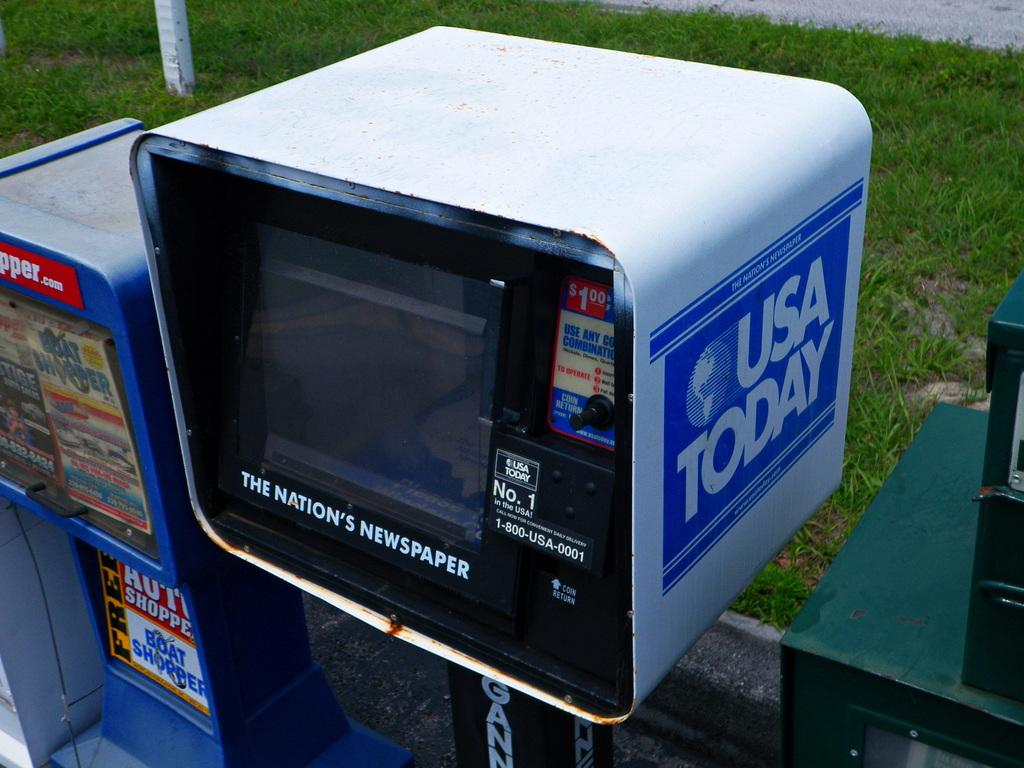<image>
Give a short and clear explanation of the subsequent image. USA Today is being sold from a machine outdoors. 